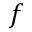Convert formula to latex. <formula><loc_0><loc_0><loc_500><loc_500>f</formula> 